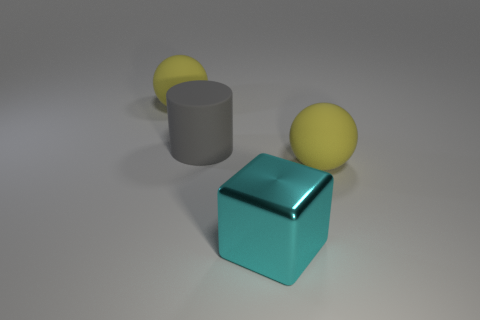What color is the large matte cylinder?
Make the answer very short. Gray. The thing that is to the right of the block right of the big yellow matte sphere that is on the left side of the large cyan thing is made of what material?
Offer a very short reply. Rubber. Is there any other thing of the same color as the big shiny object?
Offer a very short reply. No. Does the big matte object that is on the right side of the metallic thing have the same color as the large metallic object that is in front of the gray thing?
Your response must be concise. No. There is a matte ball that is in front of the big gray matte object; what is its color?
Your response must be concise. Yellow. Do the yellow sphere to the right of the matte cylinder and the large block have the same size?
Make the answer very short. Yes. Are there fewer large cyan shiny blocks than large balls?
Give a very brief answer. Yes. How many big objects are right of the cube?
Ensure brevity in your answer.  1. Do the gray object and the cyan object have the same shape?
Ensure brevity in your answer.  No. What number of things are both behind the block and in front of the gray matte object?
Offer a very short reply. 1. 